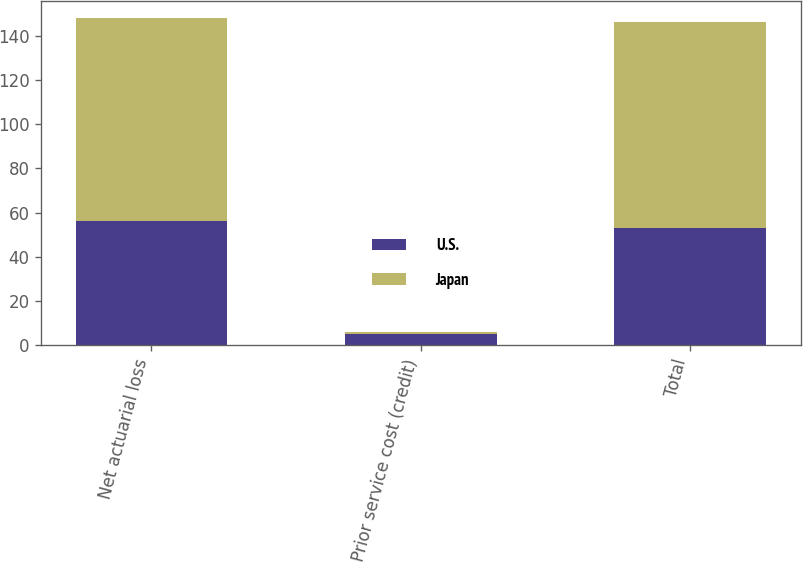<chart> <loc_0><loc_0><loc_500><loc_500><stacked_bar_chart><ecel><fcel>Net actuarial loss<fcel>Prior service cost (credit)<fcel>Total<nl><fcel>U.S.<fcel>56<fcel>5<fcel>53<nl><fcel>Japan<fcel>92<fcel>1<fcel>93<nl></chart> 